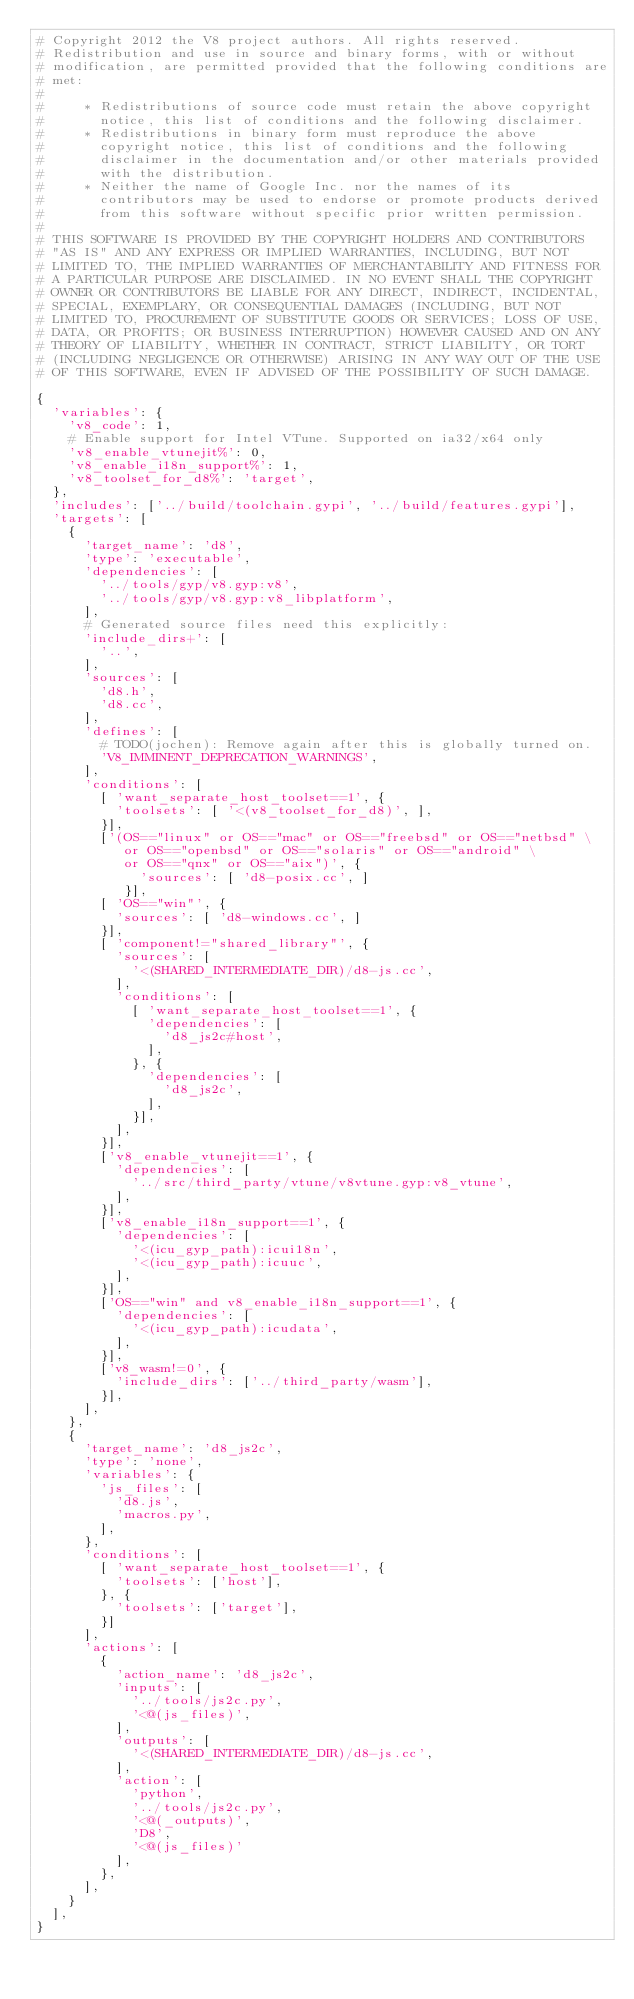<code> <loc_0><loc_0><loc_500><loc_500><_Python_># Copyright 2012 the V8 project authors. All rights reserved.
# Redistribution and use in source and binary forms, with or without
# modification, are permitted provided that the following conditions are
# met:
#
#     * Redistributions of source code must retain the above copyright
#       notice, this list of conditions and the following disclaimer.
#     * Redistributions in binary form must reproduce the above
#       copyright notice, this list of conditions and the following
#       disclaimer in the documentation and/or other materials provided
#       with the distribution.
#     * Neither the name of Google Inc. nor the names of its
#       contributors may be used to endorse or promote products derived
#       from this software without specific prior written permission.
#
# THIS SOFTWARE IS PROVIDED BY THE COPYRIGHT HOLDERS AND CONTRIBUTORS
# "AS IS" AND ANY EXPRESS OR IMPLIED WARRANTIES, INCLUDING, BUT NOT
# LIMITED TO, THE IMPLIED WARRANTIES OF MERCHANTABILITY AND FITNESS FOR
# A PARTICULAR PURPOSE ARE DISCLAIMED. IN NO EVENT SHALL THE COPYRIGHT
# OWNER OR CONTRIBUTORS BE LIABLE FOR ANY DIRECT, INDIRECT, INCIDENTAL,
# SPECIAL, EXEMPLARY, OR CONSEQUENTIAL DAMAGES (INCLUDING, BUT NOT
# LIMITED TO, PROCUREMENT OF SUBSTITUTE GOODS OR SERVICES; LOSS OF USE,
# DATA, OR PROFITS; OR BUSINESS INTERRUPTION) HOWEVER CAUSED AND ON ANY
# THEORY OF LIABILITY, WHETHER IN CONTRACT, STRICT LIABILITY, OR TORT
# (INCLUDING NEGLIGENCE OR OTHERWISE) ARISING IN ANY WAY OUT OF THE USE
# OF THIS SOFTWARE, EVEN IF ADVISED OF THE POSSIBILITY OF SUCH DAMAGE.

{
  'variables': {
    'v8_code': 1,
    # Enable support for Intel VTune. Supported on ia32/x64 only
    'v8_enable_vtunejit%': 0,
    'v8_enable_i18n_support%': 1,
    'v8_toolset_for_d8%': 'target',
  },
  'includes': ['../build/toolchain.gypi', '../build/features.gypi'],
  'targets': [
    {
      'target_name': 'd8',
      'type': 'executable',
      'dependencies': [
        '../tools/gyp/v8.gyp:v8',
        '../tools/gyp/v8.gyp:v8_libplatform',
      ],
      # Generated source files need this explicitly:
      'include_dirs+': [
        '..',
      ],
      'sources': [
        'd8.h',
        'd8.cc',
      ],
      'defines': [
        # TODO(jochen): Remove again after this is globally turned on.
        'V8_IMMINENT_DEPRECATION_WARNINGS',
      ],
      'conditions': [
        [ 'want_separate_host_toolset==1', {
          'toolsets': [ '<(v8_toolset_for_d8)', ],
        }],
        ['(OS=="linux" or OS=="mac" or OS=="freebsd" or OS=="netbsd" \
           or OS=="openbsd" or OS=="solaris" or OS=="android" \
           or OS=="qnx" or OS=="aix")', {
             'sources': [ 'd8-posix.cc', ]
           }],
        [ 'OS=="win"', {
          'sources': [ 'd8-windows.cc', ]
        }],
        [ 'component!="shared_library"', {
          'sources': [
            '<(SHARED_INTERMEDIATE_DIR)/d8-js.cc',
          ],
          'conditions': [
            [ 'want_separate_host_toolset==1', {
              'dependencies': [
                'd8_js2c#host',
              ],
            }, {
              'dependencies': [
                'd8_js2c',
              ],
            }],
          ],
        }],
        ['v8_enable_vtunejit==1', {
          'dependencies': [
            '../src/third_party/vtune/v8vtune.gyp:v8_vtune',
          ],
        }],
        ['v8_enable_i18n_support==1', {
          'dependencies': [
            '<(icu_gyp_path):icui18n',
            '<(icu_gyp_path):icuuc',
          ],
        }],
        ['OS=="win" and v8_enable_i18n_support==1', {
          'dependencies': [
            '<(icu_gyp_path):icudata',
          ],
        }],
        ['v8_wasm!=0', {
          'include_dirs': ['../third_party/wasm'],
        }],
      ],
    },
    {
      'target_name': 'd8_js2c',
      'type': 'none',
      'variables': {
        'js_files': [
          'd8.js',
          'macros.py',
        ],
      },
      'conditions': [
        [ 'want_separate_host_toolset==1', {
          'toolsets': ['host'],
        }, {
          'toolsets': ['target'],
        }]
      ],
      'actions': [
        {
          'action_name': 'd8_js2c',
          'inputs': [
            '../tools/js2c.py',
            '<@(js_files)',
          ],
          'outputs': [
            '<(SHARED_INTERMEDIATE_DIR)/d8-js.cc',
          ],
          'action': [
            'python',
            '../tools/js2c.py',
            '<@(_outputs)',
            'D8',
            '<@(js_files)'
          ],
        },
      ],
    }
  ],
}
</code> 